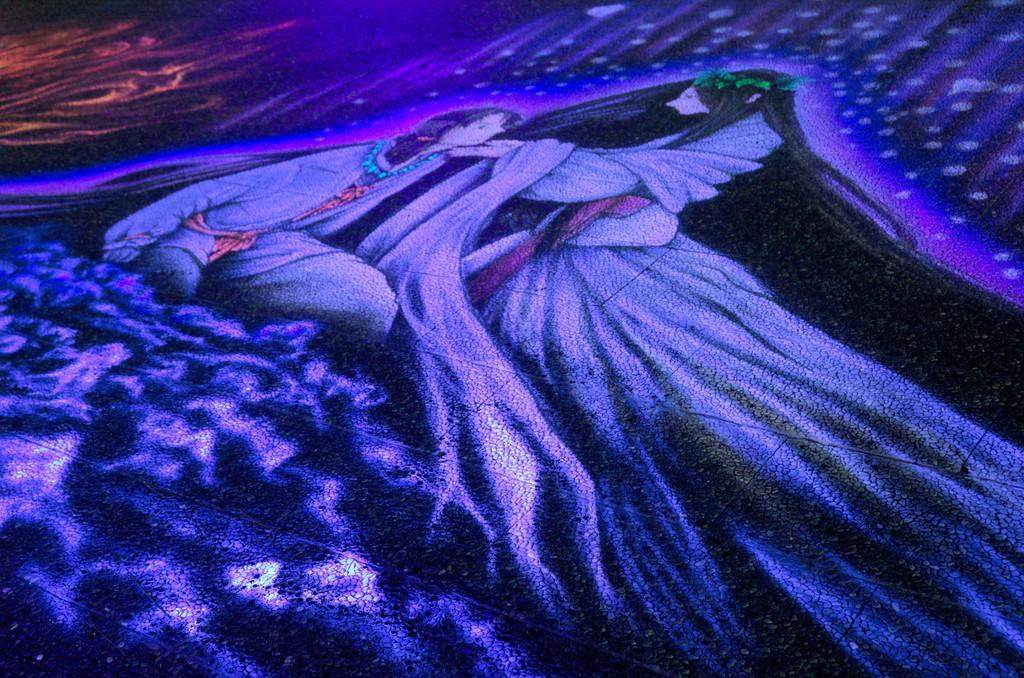What is the main subject of the image? There is a painting in the image. What does the painting depict? The painting depicts two people. What type of tank is visible in the painting? There is no tank present in the painting; it depicts two people. How much money is being exchanged between the two people in the painting? There is no indication of money or any exchange in the painting; it simply depicts two people. 